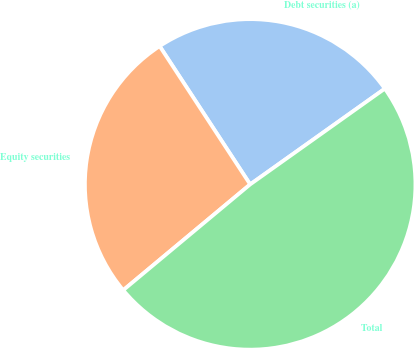<chart> <loc_0><loc_0><loc_500><loc_500><pie_chart><fcel>Debt securities (a)<fcel>Equity securities<fcel>Total<nl><fcel>24.39%<fcel>26.83%<fcel>48.78%<nl></chart> 